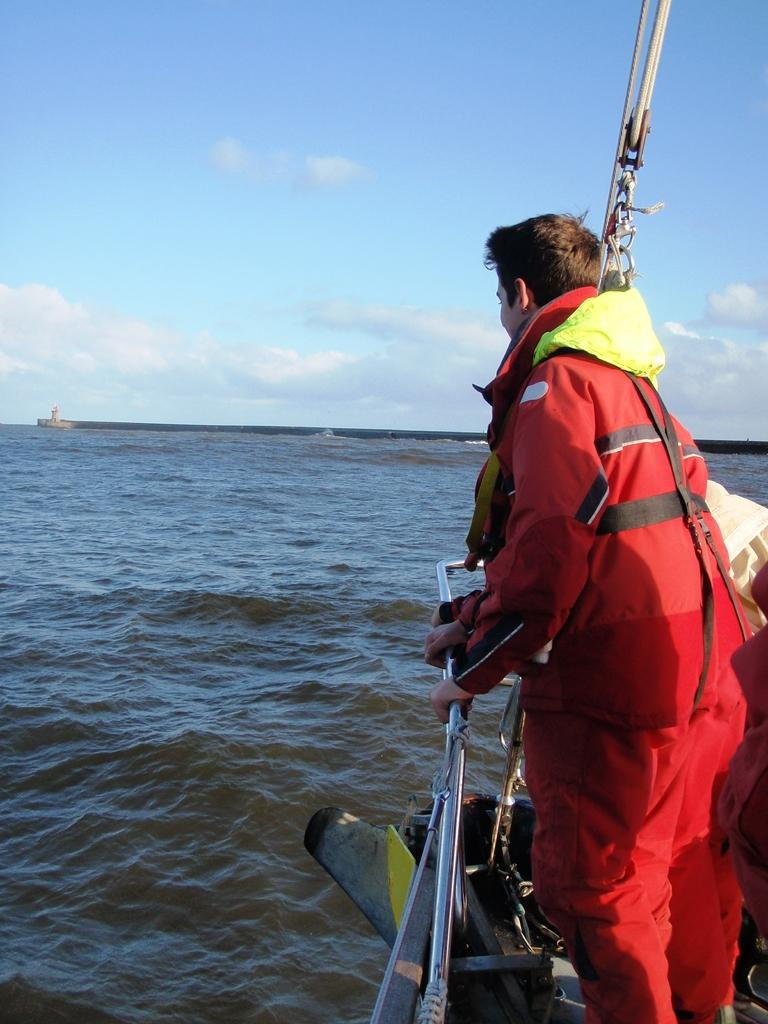What is the person in the image wearing? The person in the image is wearing a swimsuit. What activity is the person engaged in? The person is sailing in a boat. What type of environment is visible in the image? There is water, a lighthouse, and the sky visible in the image. What is the condition of the sky in the image? The sky is visible with clouds in the image. What objects can be seen in the top right corner of the image? There are some objects in the top right corner of the image, but their specific nature is not mentioned in the facts. What type of glass is the person holding in the image? There is no mention of glass in the image. 